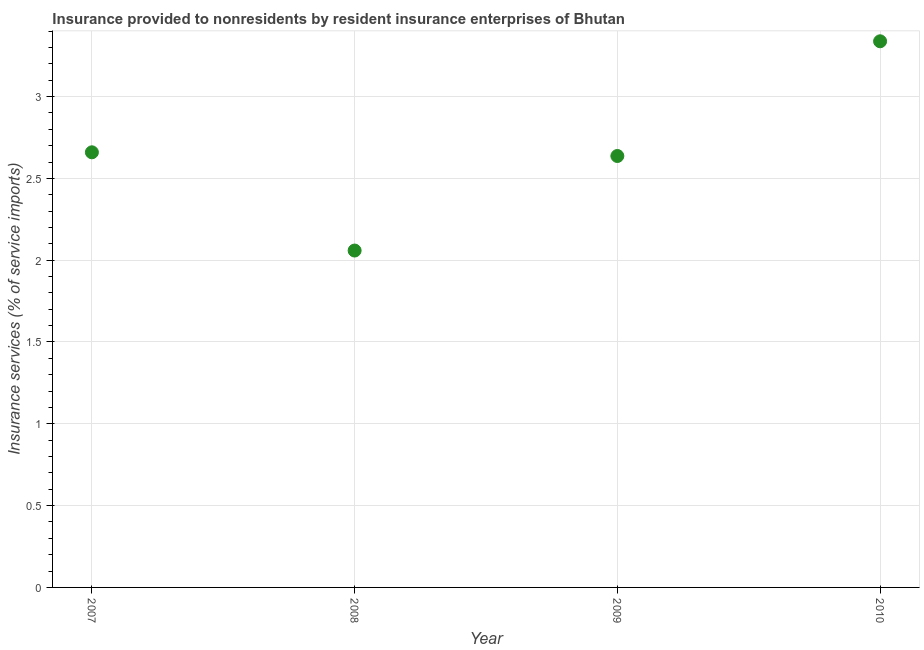What is the insurance and financial services in 2010?
Ensure brevity in your answer.  3.34. Across all years, what is the maximum insurance and financial services?
Make the answer very short. 3.34. Across all years, what is the minimum insurance and financial services?
Keep it short and to the point. 2.06. In which year was the insurance and financial services maximum?
Your answer should be very brief. 2010. What is the sum of the insurance and financial services?
Make the answer very short. 10.69. What is the difference between the insurance and financial services in 2007 and 2010?
Give a very brief answer. -0.68. What is the average insurance and financial services per year?
Provide a short and direct response. 2.67. What is the median insurance and financial services?
Make the answer very short. 2.65. Do a majority of the years between 2010 and 2008 (inclusive) have insurance and financial services greater than 1.2 %?
Your response must be concise. No. What is the ratio of the insurance and financial services in 2009 to that in 2010?
Your answer should be very brief. 0.79. Is the difference between the insurance and financial services in 2009 and 2010 greater than the difference between any two years?
Your response must be concise. No. What is the difference between the highest and the second highest insurance and financial services?
Your answer should be compact. 0.68. Is the sum of the insurance and financial services in 2007 and 2010 greater than the maximum insurance and financial services across all years?
Make the answer very short. Yes. What is the difference between the highest and the lowest insurance and financial services?
Provide a succinct answer. 1.28. How many years are there in the graph?
Give a very brief answer. 4. What is the difference between two consecutive major ticks on the Y-axis?
Your answer should be very brief. 0.5. Does the graph contain any zero values?
Give a very brief answer. No. What is the title of the graph?
Offer a very short reply. Insurance provided to nonresidents by resident insurance enterprises of Bhutan. What is the label or title of the X-axis?
Make the answer very short. Year. What is the label or title of the Y-axis?
Provide a short and direct response. Insurance services (% of service imports). What is the Insurance services (% of service imports) in 2007?
Provide a short and direct response. 2.66. What is the Insurance services (% of service imports) in 2008?
Keep it short and to the point. 2.06. What is the Insurance services (% of service imports) in 2009?
Provide a short and direct response. 2.64. What is the Insurance services (% of service imports) in 2010?
Your answer should be very brief. 3.34. What is the difference between the Insurance services (% of service imports) in 2007 and 2008?
Make the answer very short. 0.6. What is the difference between the Insurance services (% of service imports) in 2007 and 2009?
Keep it short and to the point. 0.02. What is the difference between the Insurance services (% of service imports) in 2007 and 2010?
Keep it short and to the point. -0.68. What is the difference between the Insurance services (% of service imports) in 2008 and 2009?
Your answer should be very brief. -0.58. What is the difference between the Insurance services (% of service imports) in 2008 and 2010?
Your answer should be compact. -1.28. What is the difference between the Insurance services (% of service imports) in 2009 and 2010?
Your response must be concise. -0.7. What is the ratio of the Insurance services (% of service imports) in 2007 to that in 2008?
Offer a terse response. 1.29. What is the ratio of the Insurance services (% of service imports) in 2007 to that in 2009?
Your answer should be compact. 1.01. What is the ratio of the Insurance services (% of service imports) in 2007 to that in 2010?
Your answer should be very brief. 0.8. What is the ratio of the Insurance services (% of service imports) in 2008 to that in 2009?
Ensure brevity in your answer.  0.78. What is the ratio of the Insurance services (% of service imports) in 2008 to that in 2010?
Keep it short and to the point. 0.62. What is the ratio of the Insurance services (% of service imports) in 2009 to that in 2010?
Give a very brief answer. 0.79. 